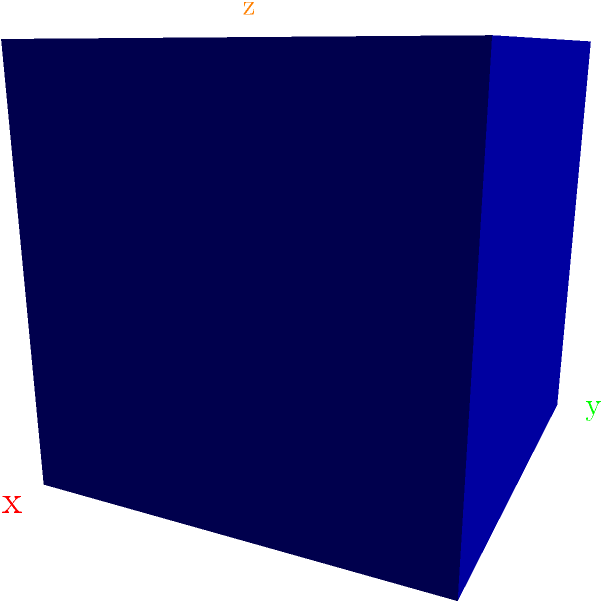A historical artifact in your museum is modeled as a cube. The rotation group of this cube consists of 24 elements. If you apply a 120-degree rotation around the body diagonal (from one corner to the opposite corner) of the cube, how many more rotations of the same type would you need to apply to return the cube to its original orientation? To solve this problem, we need to understand the properties of rotations in the cube's symmetry group:

1. The rotation group of a cube has 24 elements, including the identity rotation.

2. A 120-degree rotation around a body diagonal is a 3-fold rotation, meaning it takes three such rotations to return to the original position.

3. To calculate the number of additional rotations needed:
   a. Let $x$ be the number of additional rotations needed.
   b. The total number of rotations (including the first one) should be divisible by 3.
   c. This can be expressed as: $x + 1 \equiv 0 \pmod{3}$

4. Solving the congruence:
   $x + 1 \equiv 0 \pmod{3}$
   $x \equiv -1 \pmod{3}$
   $x \equiv 2 \pmod{3}$

5. Therefore, we need 2 more rotations of 120 degrees around the same body diagonal to return the cube to its original orientation.
Answer: 2 